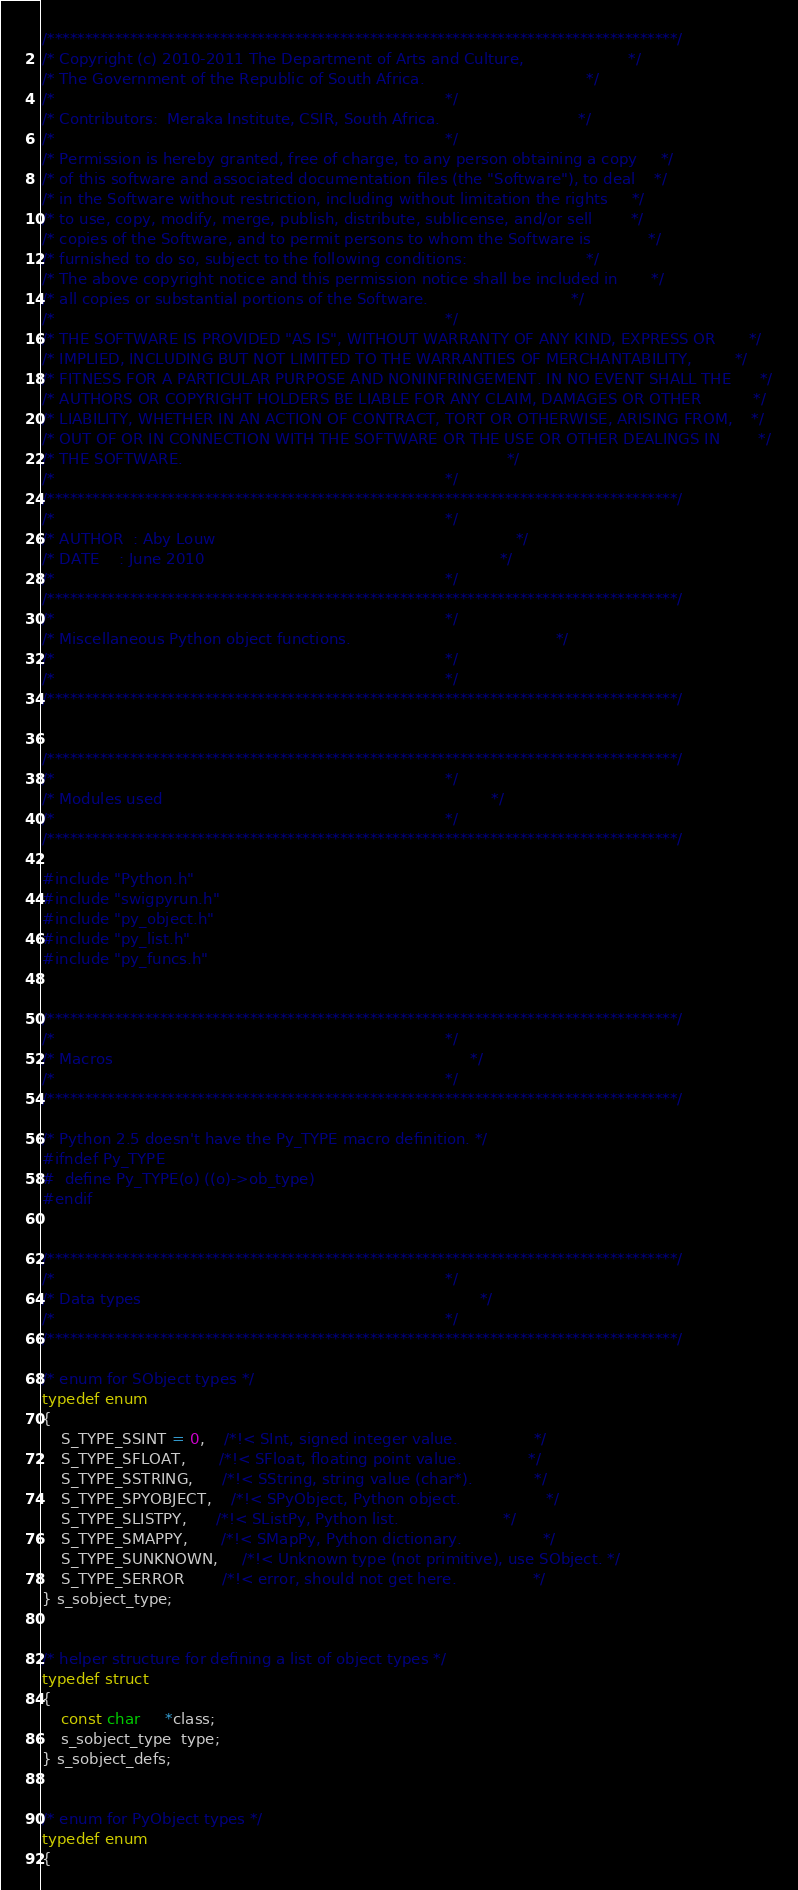Convert code to text. <code><loc_0><loc_0><loc_500><loc_500><_C_>/************************************************************************************/
/* Copyright (c) 2010-2011 The Department of Arts and Culture,                      */
/* The Government of the Republic of South Africa.                                  */
/*                                                                                  */
/* Contributors:  Meraka Institute, CSIR, South Africa.                             */
/*                                                                                  */
/* Permission is hereby granted, free of charge, to any person obtaining a copy     */
/* of this software and associated documentation files (the "Software"), to deal    */
/* in the Software without restriction, including without limitation the rights     */
/* to use, copy, modify, merge, publish, distribute, sublicense, and/or sell        */
/* copies of the Software, and to permit persons to whom the Software is            */
/* furnished to do so, subject to the following conditions:                         */
/* The above copyright notice and this permission notice shall be included in       */
/* all copies or substantial portions of the Software.                              */
/*                                                                                  */
/* THE SOFTWARE IS PROVIDED "AS IS", WITHOUT WARRANTY OF ANY KIND, EXPRESS OR       */
/* IMPLIED, INCLUDING BUT NOT LIMITED TO THE WARRANTIES OF MERCHANTABILITY,         */
/* FITNESS FOR A PARTICULAR PURPOSE AND NONINFRINGEMENT. IN NO EVENT SHALL THE      */
/* AUTHORS OR COPYRIGHT HOLDERS BE LIABLE FOR ANY CLAIM, DAMAGES OR OTHER           */
/* LIABILITY, WHETHER IN AN ACTION OF CONTRACT, TORT OR OTHERWISE, ARISING FROM,    */
/* OUT OF OR IN CONNECTION WITH THE SOFTWARE OR THE USE OR OTHER DEALINGS IN        */
/* THE SOFTWARE.                                                                    */
/*                                                                                  */
/************************************************************************************/
/*                                                                                  */
/* AUTHOR  : Aby Louw                                                               */
/* DATE    : June 2010                                                              */
/*                                                                                  */
/************************************************************************************/
/*                                                                                  */
/* Miscellaneous Python object functions.                                           */
/*                                                                                  */
/*                                                                                  */
/************************************************************************************/


/************************************************************************************/
/*                                                                                  */
/* Modules used                                                                     */
/*                                                                                  */
/************************************************************************************/

#include "Python.h"
#include "swigpyrun.h"
#include "py_object.h"
#include "py_list.h"
#include "py_funcs.h"


/************************************************************************************/
/*                                                                                  */
/* Macros                                                                           */
/*                                                                                  */
/************************************************************************************/

/* Python 2.5 doesn't have the Py_TYPE macro definition. */
#ifndef Py_TYPE
#  define Py_TYPE(o) ((o)->ob_type)
#endif


/************************************************************************************/
/*                                                                                  */
/* Data types                                                                       */
/*                                                                                  */
/************************************************************************************/

/* enum for SObject types */
typedef enum
{
	S_TYPE_SSINT = 0,    /*!< SInt, signed integer value.                */
	S_TYPE_SFLOAT,       /*!< SFloat, floating point value.              */
	S_TYPE_SSTRING,      /*!< SString, string value (char*).             */
	S_TYPE_SPYOBJECT,    /*!< SPyObject, Python object.                  */
	S_TYPE_SLISTPY,      /*!< SListPy, Python list.                      */
	S_TYPE_SMAPPY,       /*!< SMapPy, Python dictionary.                 */
	S_TYPE_SUNKNOWN,     /*!< Unknown type (not primitive), use SObject. */
	S_TYPE_SERROR        /*!< error, should not get here.                */
} s_sobject_type;


/* helper structure for defining a list of object types */
typedef struct
{
	const char     *class;
	s_sobject_type  type;
} s_sobject_defs;


/* enum for PyObject types */
typedef enum
{</code> 